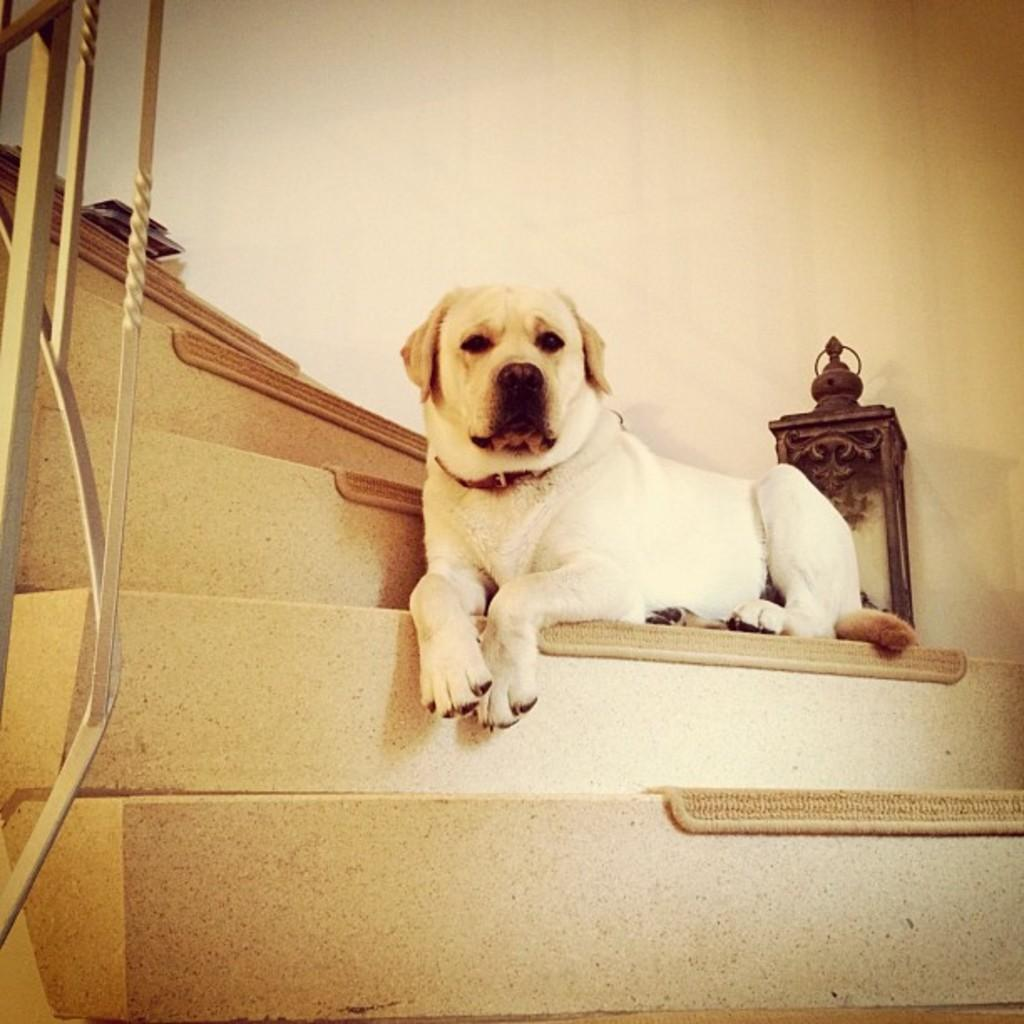What animal can be seen in the image? There is a dog in the image. Where is the dog located in the image? The dog is on the stairs. What can be seen in the background of the image? There is a wall in the background of the image. What type of needle is the dog holding in the image? There is no needle present in the image; the dog is not holding anything. 